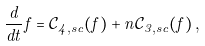Convert formula to latex. <formula><loc_0><loc_0><loc_500><loc_500>\frac { d } { d t } f = \mathcal { C } _ { 4 , s c } ( f ) + n \mathcal { C } _ { 3 , s c } ( f ) \, ,</formula> 